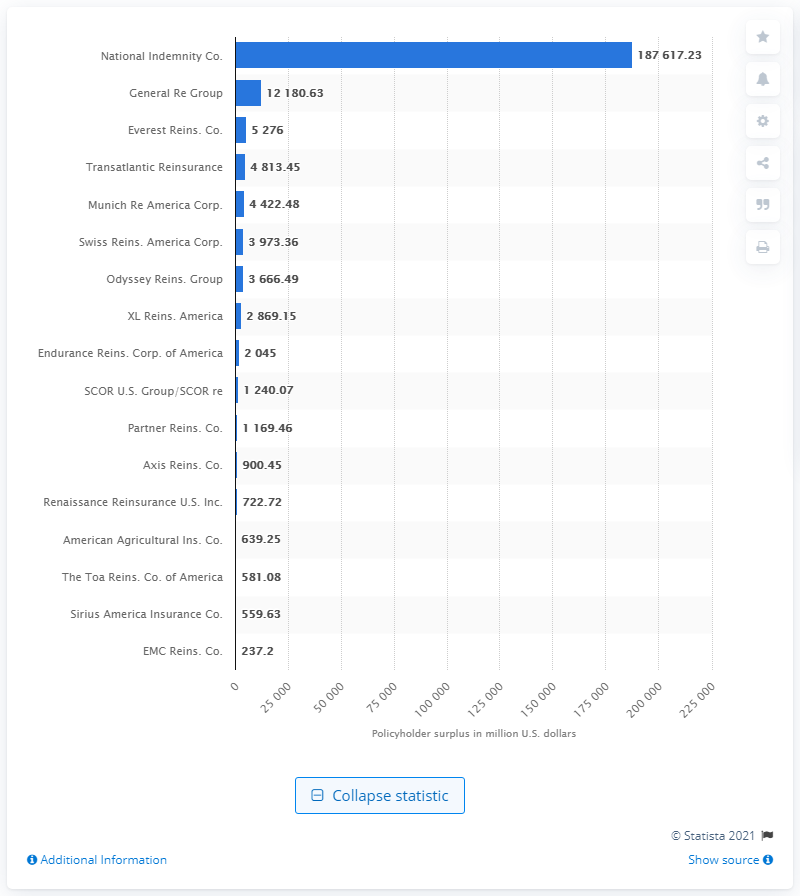Draw attention to some important aspects in this diagram. The policyholder surplus of National Indemnity Company in 2020 was 187,617.23 dollars. 